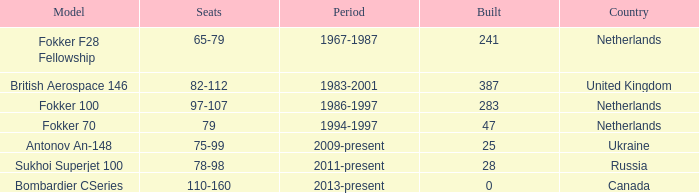During which years were 241 fokker 70 model cabins assembled? 1994-1997. 